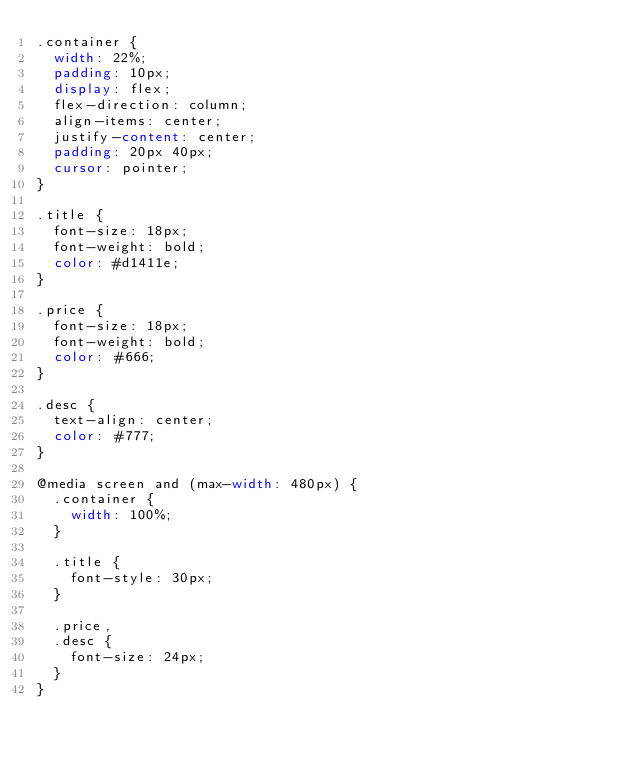<code> <loc_0><loc_0><loc_500><loc_500><_CSS_>.container {
  width: 22%;
  padding: 10px;
  display: flex;
  flex-direction: column;
  align-items: center;
  justify-content: center;
  padding: 20px 40px;
  cursor: pointer;
}

.title {
  font-size: 18px;
  font-weight: bold;
  color: #d1411e;
}

.price {
  font-size: 18px;
  font-weight: bold;
  color: #666;
}

.desc {
  text-align: center;
  color: #777;
}

@media screen and (max-width: 480px) {
  .container {
    width: 100%;
  }

  .title {
    font-style: 30px;
  }

  .price,
  .desc {
    font-size: 24px;
  }
}
</code> 